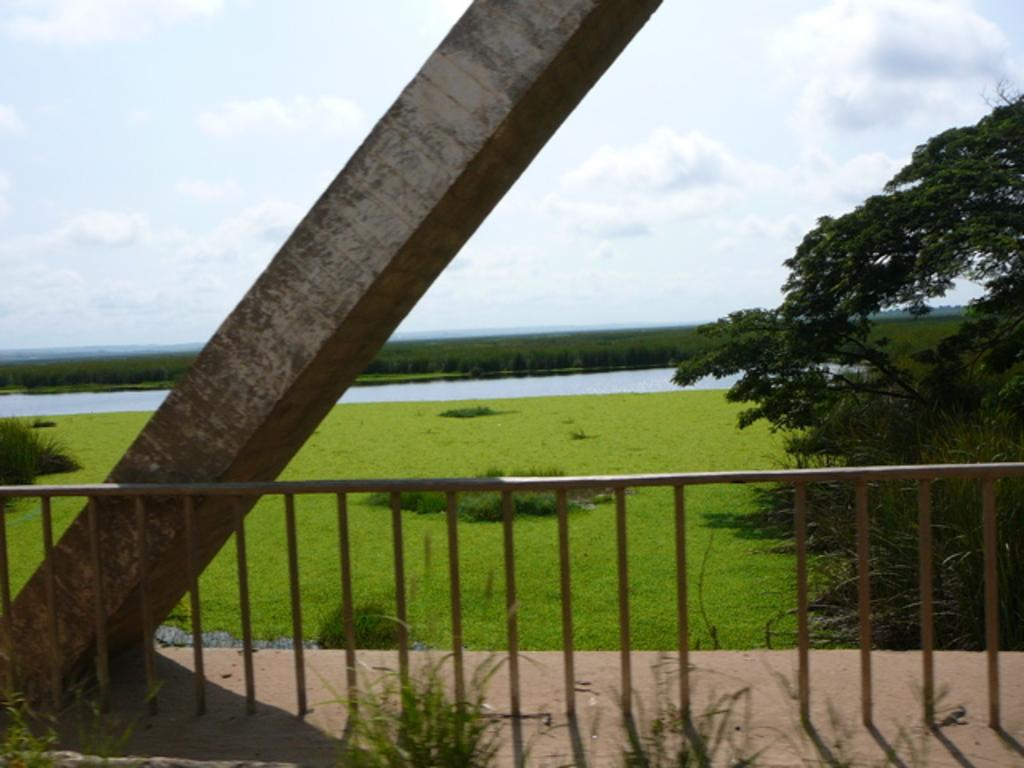What type of natural elements can be seen in the image? There are trees in the image. What architectural feature is present in the image? There is a pillar in the image. What type of barrier can be seen in the image? There is fencing in the image. What body of water is visible in the image? There is water visible in the image. What colors are used to depict the sky in the image? The sky is in white and blue color in the image. What type of meal is being served on the table in the image? There is no table or meal present in the image; it features trees, a pillar, fencing, water, and a sky with white and blue colors. What type of thread is used to create the fencing in the image? The image does not provide information about the type of thread used for the fencing; it only shows the presence of fencing. 